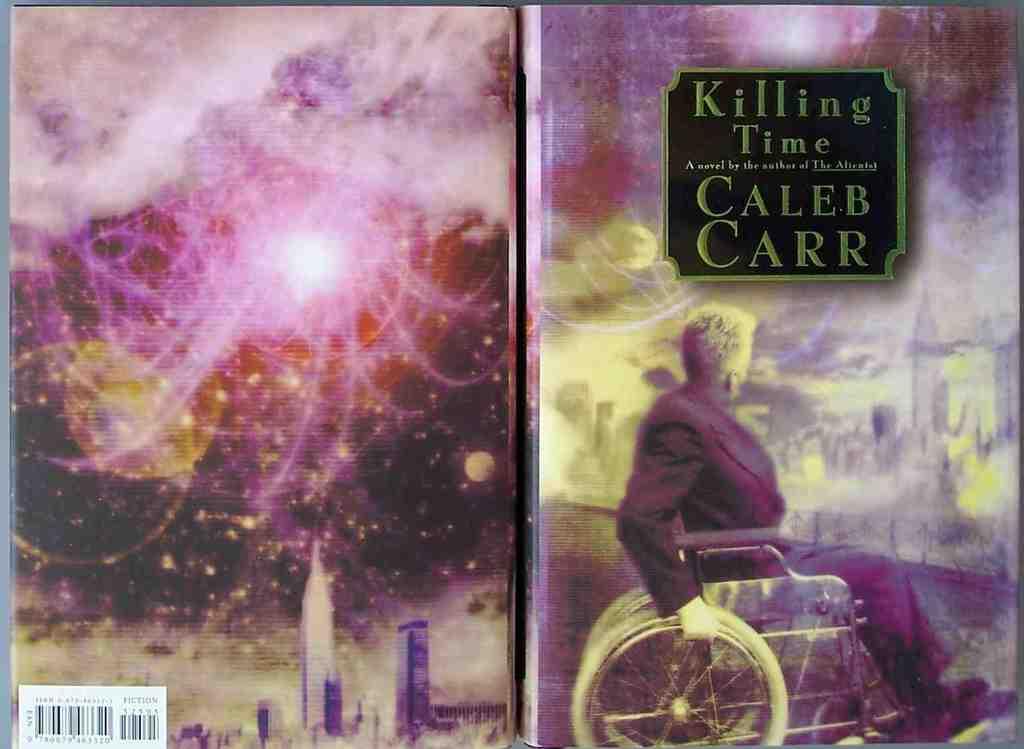Who is the author of this novel?
Offer a very short reply. Caleb carr. 